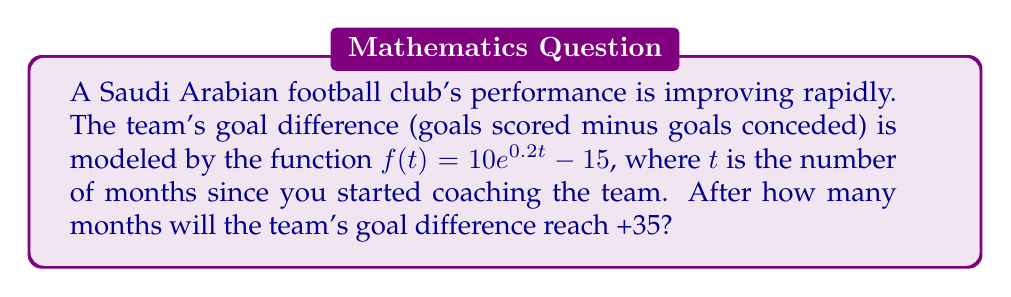Could you help me with this problem? To solve this problem, we need to follow these steps:

1) We want to find $t$ when $f(t) = 35$. So, we set up the equation:

   $35 = 10e^{0.2t} - 15$

2) Add 15 to both sides:

   $50 = 10e^{0.2t}$

3) Divide both sides by 10:

   $5 = e^{0.2t}$

4) Take the natural logarithm of both sides:

   $\ln(5) = \ln(e^{0.2t})$

5) Simplify the right side using the property of logarithms:

   $\ln(5) = 0.2t$

6) Divide both sides by 0.2:

   $\frac{\ln(5)}{0.2} = t$

7) Calculate the value:

   $t = \frac{\ln(5)}{0.2} \approx 8.047$ months

8) Since we can't have a fractional month in this context, we round up to the next whole month.
Answer: 9 months 